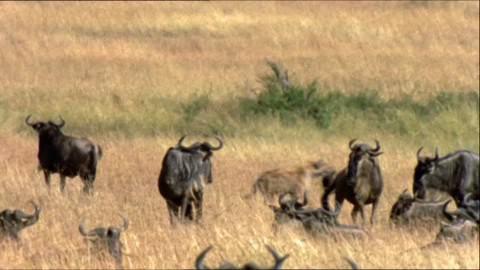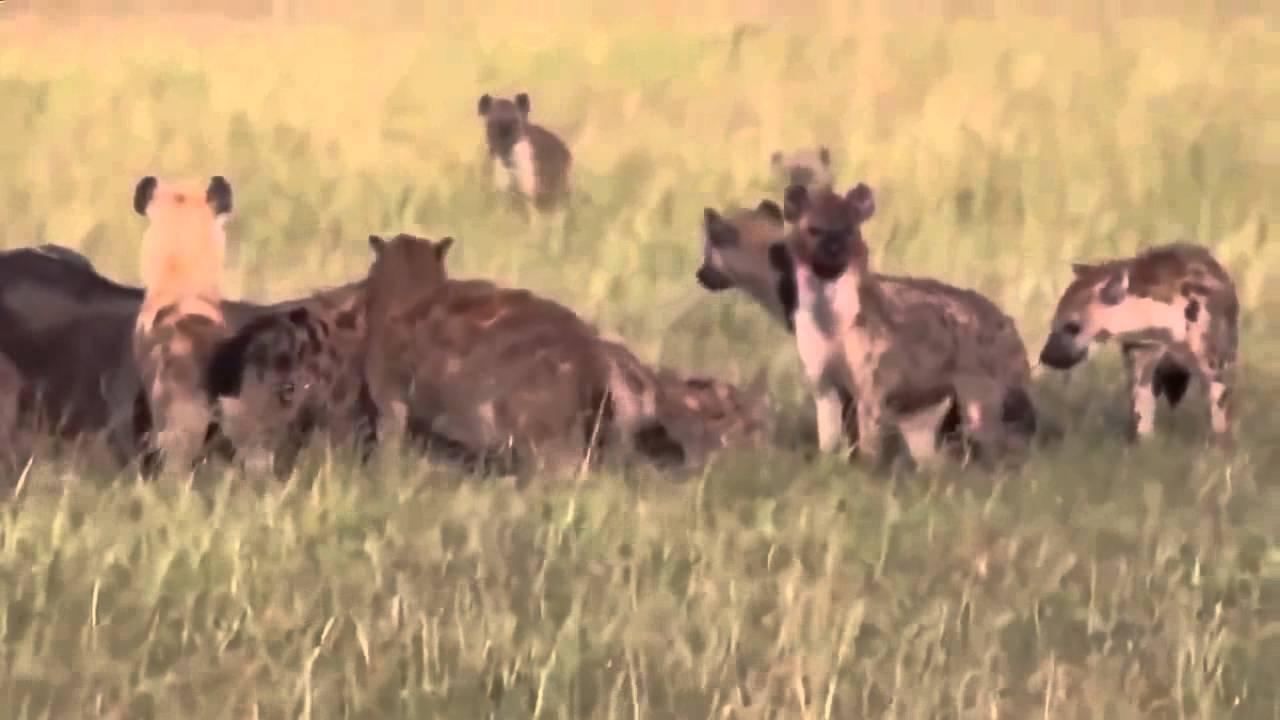The first image is the image on the left, the second image is the image on the right. For the images shown, is this caption "One of the images shows hyenas hunting and the other shows them eating after a successful hunt." true? Answer yes or no. Yes. The first image is the image on the left, the second image is the image on the right. Analyze the images presented: Is the assertion "One image includes one standing water buffalo in the foreground near multiple hyenas, and the other image shows a pack of hyenas gathered around something on the ground." valid? Answer yes or no. No. 